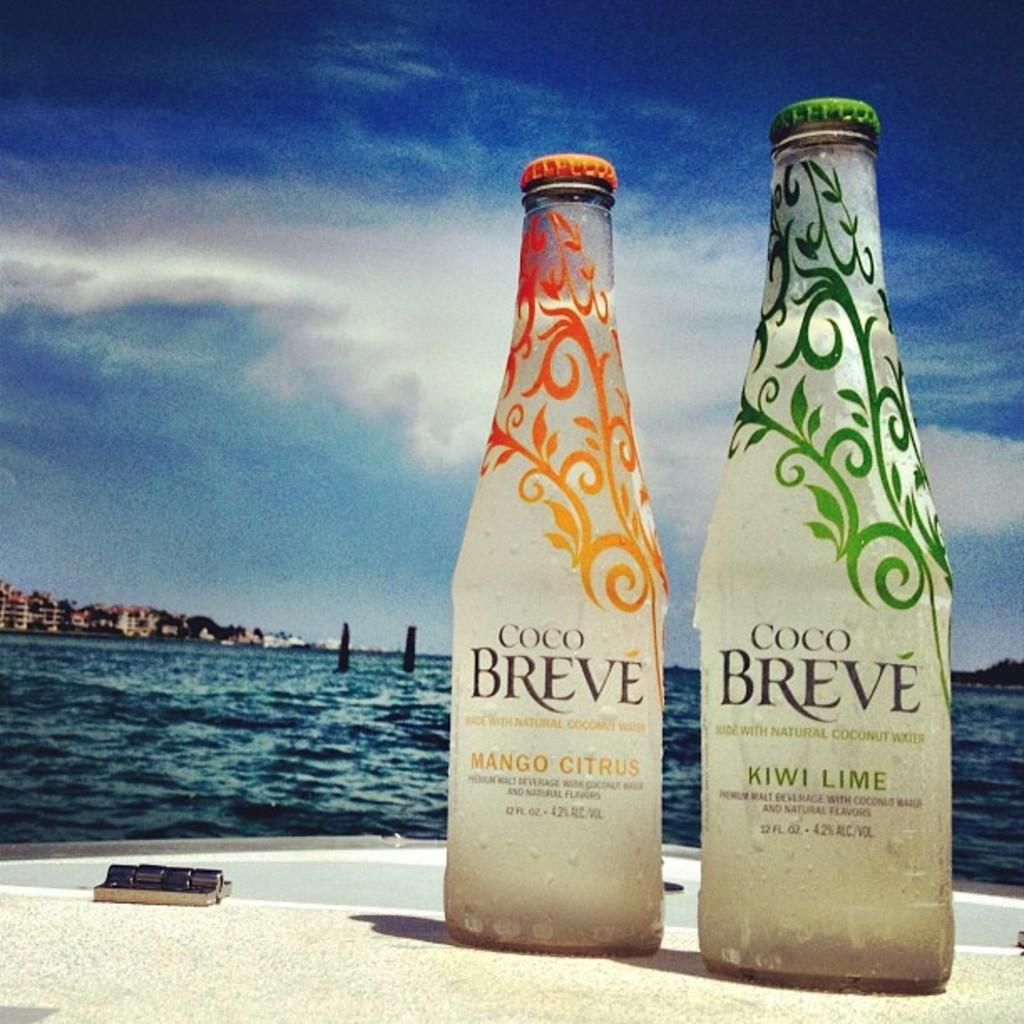<image>
Provide a brief description of the given image. Two bottles of Coco Breve coconut water with the Mango Citrus and Kiwi Lime flavors respectively. 